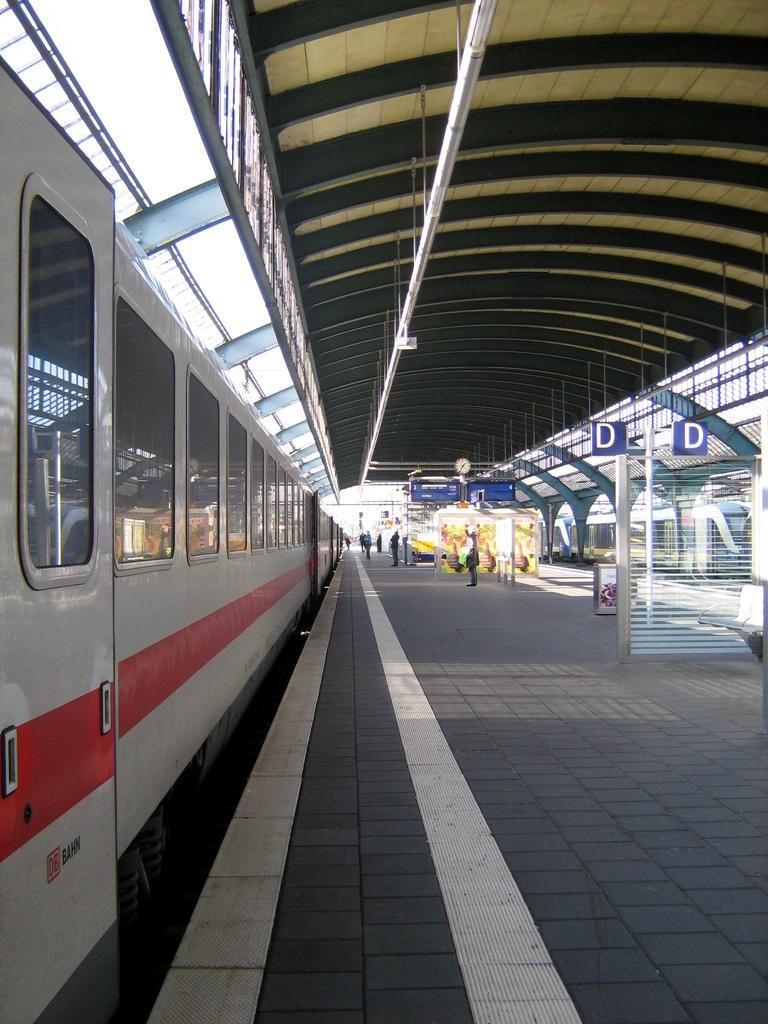What is the main subject of the image? There is a vehicle in the image. What else can be seen in the image besides the vehicle? There is a platform, people, poles, boards, and other objects in the image. Can you describe the platform in the image? The platform is a raised surface that the vehicle and people are on. What is visible in the background of the image? The sky is visible in the background of the image. Is the wax melting on the boards in the image? There is no wax present in the image, so it cannot be melting on the boards. 